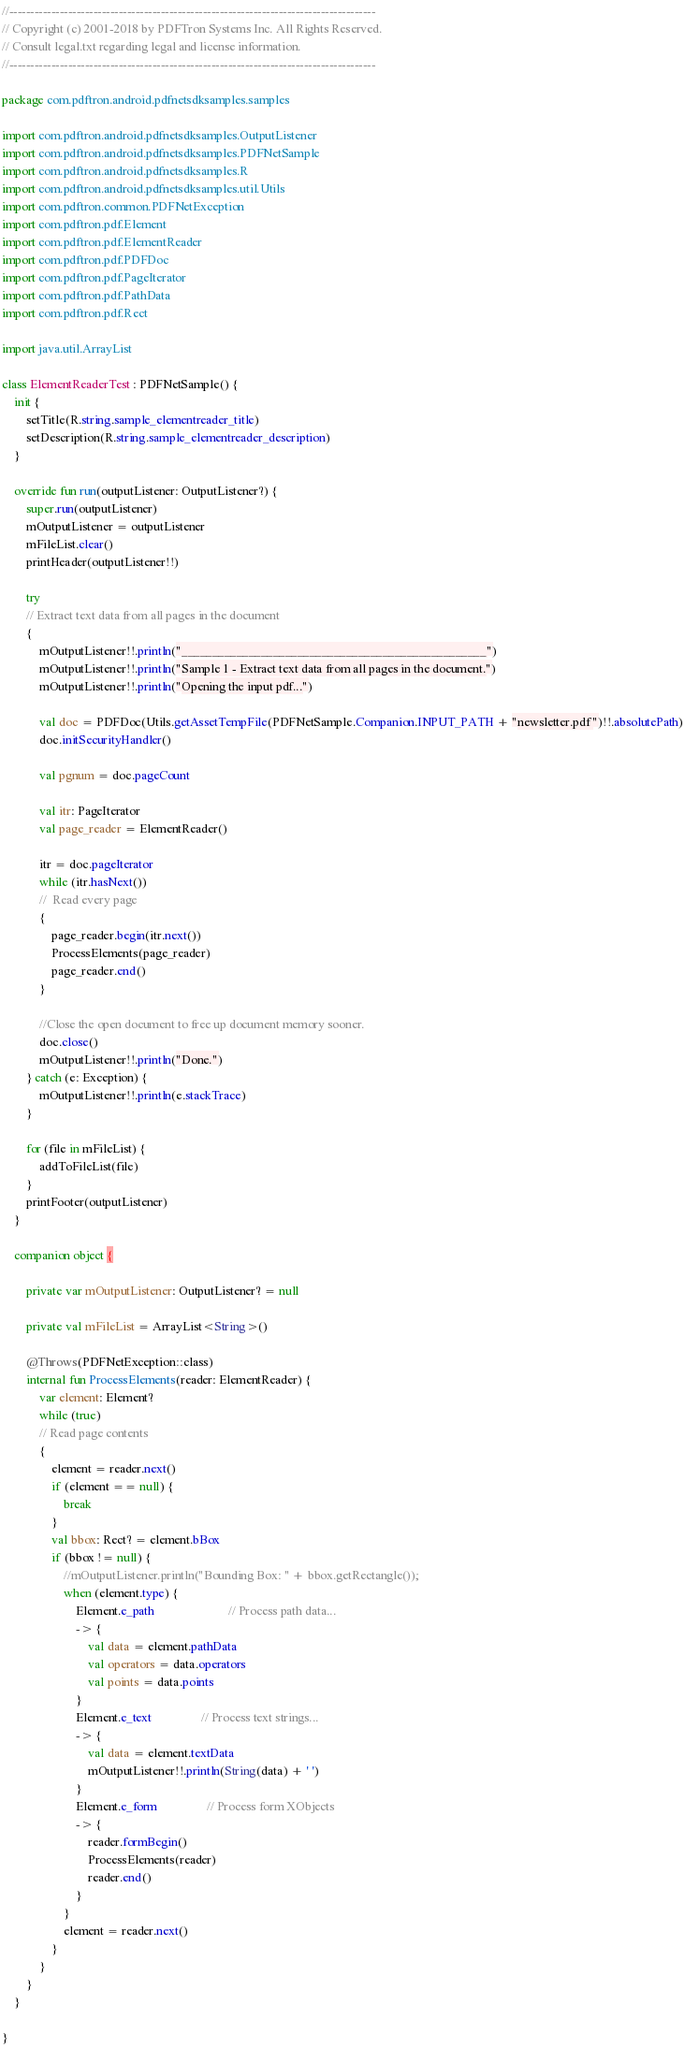Convert code to text. <code><loc_0><loc_0><loc_500><loc_500><_Kotlin_>//---------------------------------------------------------------------------------------
// Copyright (c) 2001-2018 by PDFTron Systems Inc. All Rights Reserved.
// Consult legal.txt regarding legal and license information.
//---------------------------------------------------------------------------------------

package com.pdftron.android.pdfnetsdksamples.samples

import com.pdftron.android.pdfnetsdksamples.OutputListener
import com.pdftron.android.pdfnetsdksamples.PDFNetSample
import com.pdftron.android.pdfnetsdksamples.R
import com.pdftron.android.pdfnetsdksamples.util.Utils
import com.pdftron.common.PDFNetException
import com.pdftron.pdf.Element
import com.pdftron.pdf.ElementReader
import com.pdftron.pdf.PDFDoc
import com.pdftron.pdf.PageIterator
import com.pdftron.pdf.PathData
import com.pdftron.pdf.Rect

import java.util.ArrayList

class ElementReaderTest : PDFNetSample() {
    init {
        setTitle(R.string.sample_elementreader_title)
        setDescription(R.string.sample_elementreader_description)
    }

    override fun run(outputListener: OutputListener?) {
        super.run(outputListener)
        mOutputListener = outputListener
        mFileList.clear()
        printHeader(outputListener!!)

        try
        // Extract text data from all pages in the document
        {
            mOutputListener!!.println("__________________________________________________")
            mOutputListener!!.println("Sample 1 - Extract text data from all pages in the document.")
            mOutputListener!!.println("Opening the input pdf...")

            val doc = PDFDoc(Utils.getAssetTempFile(PDFNetSample.Companion.INPUT_PATH + "newsletter.pdf")!!.absolutePath)
            doc.initSecurityHandler()

            val pgnum = doc.pageCount

            val itr: PageIterator
            val page_reader = ElementReader()

            itr = doc.pageIterator
            while (itr.hasNext())
            //  Read every page
            {
                page_reader.begin(itr.next())
                ProcessElements(page_reader)
                page_reader.end()
            }

            //Close the open document to free up document memory sooner.
            doc.close()
            mOutputListener!!.println("Done.")
        } catch (e: Exception) {
            mOutputListener!!.println(e.stackTrace)
        }

        for (file in mFileList) {
            addToFileList(file)
        }
        printFooter(outputListener)
    }

    companion object {

        private var mOutputListener: OutputListener? = null

        private val mFileList = ArrayList<String>()

        @Throws(PDFNetException::class)
        internal fun ProcessElements(reader: ElementReader) {
            var element: Element?
            while (true)
            // Read page contents
            {
                element = reader.next()
                if (element == null) {
                    break
                }
                val bbox: Rect? = element.bBox
                if (bbox != null) {
                    //mOutputListener.println("Bounding Box: " + bbox.getRectangle());
                    when (element.type) {
                        Element.e_path                        // Process path data...
                        -> {
                            val data = element.pathData
                            val operators = data.operators
                            val points = data.points
                        }
                        Element.e_text                // Process text strings...
                        -> {
                            val data = element.textData
                            mOutputListener!!.println(String(data) + ' ')
                        }
                        Element.e_form                // Process form XObjects
                        -> {
                            reader.formBegin()
                            ProcessElements(reader)
                            reader.end()
                        }
                    }
                    element = reader.next()
                }
            }
        }
    }

}</code> 